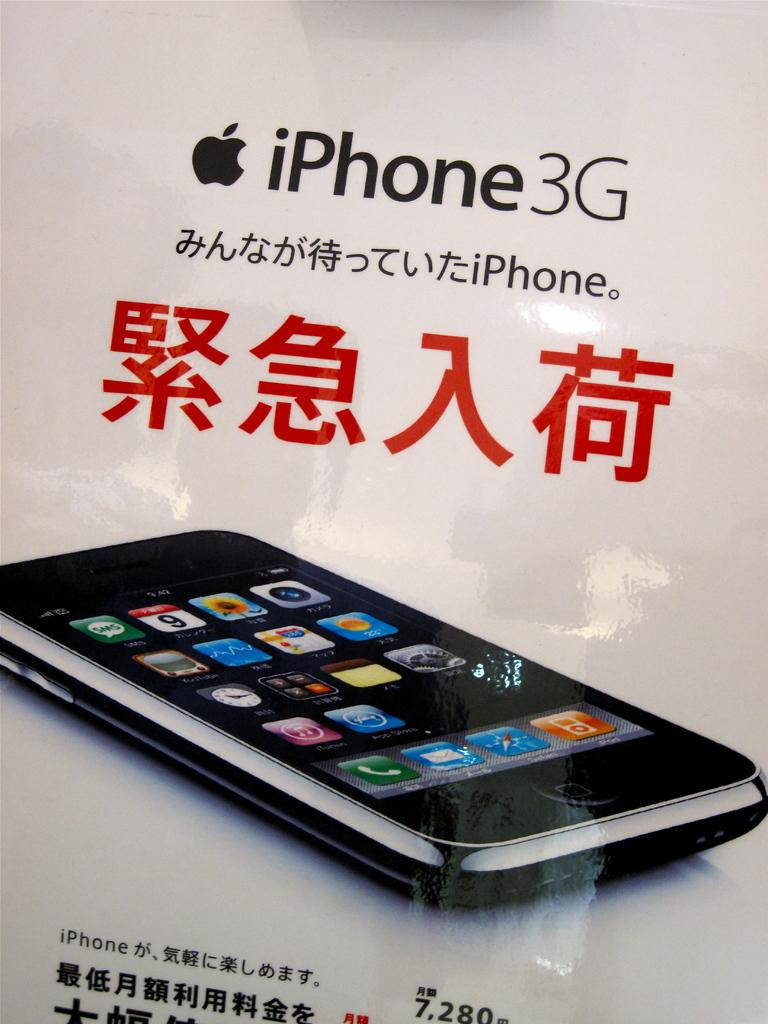Provide a one-sentence caption for the provided image. The poster shown is of the iPhone3G with foreign writing accompanying it. 